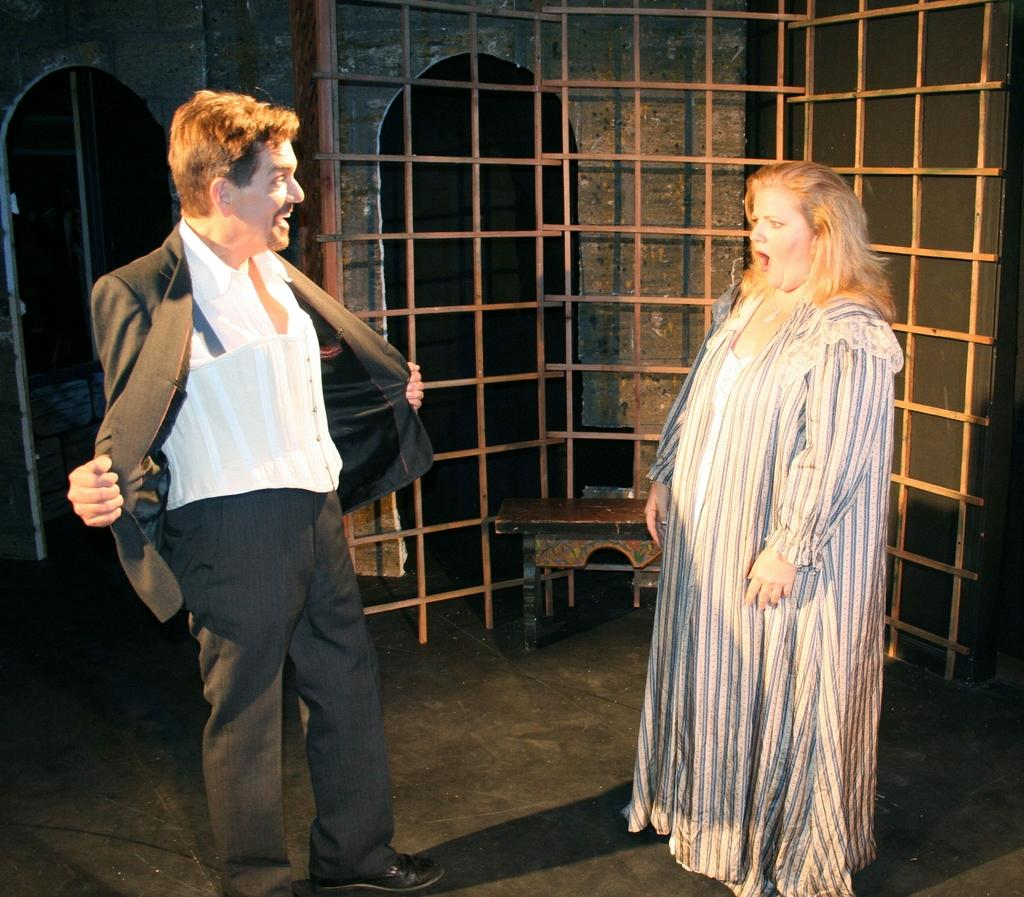How many people are in the image? There are two persons standing in the image. What is the surface on which the persons are standing? The persons are standing on the floor. What piece of furniture can be seen in the image? There is a bench in the image. What is the cooking appliance visible in the image? There is a grill in the image. What can be seen in the distance in the image? There is a building visible in the background of the image. What type of pie is being served on the wheel in the image? There is no pie or wheel present in the image. How does the brake system work on the grill in the image? There is no brake system on the grill in the image; it is a cooking appliance. 